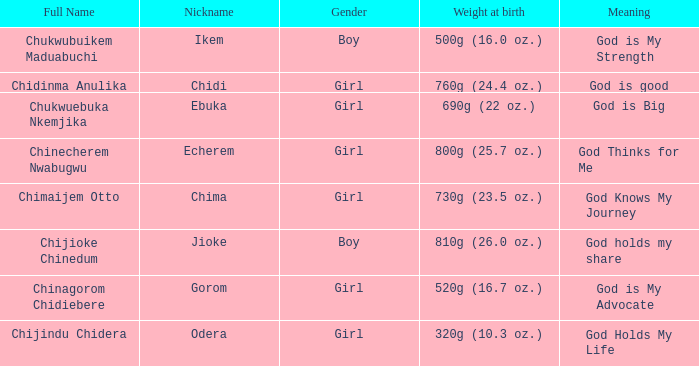How much did the girl, nicknamed Chidi, weigh at birth? 760g (24.4 oz.). 